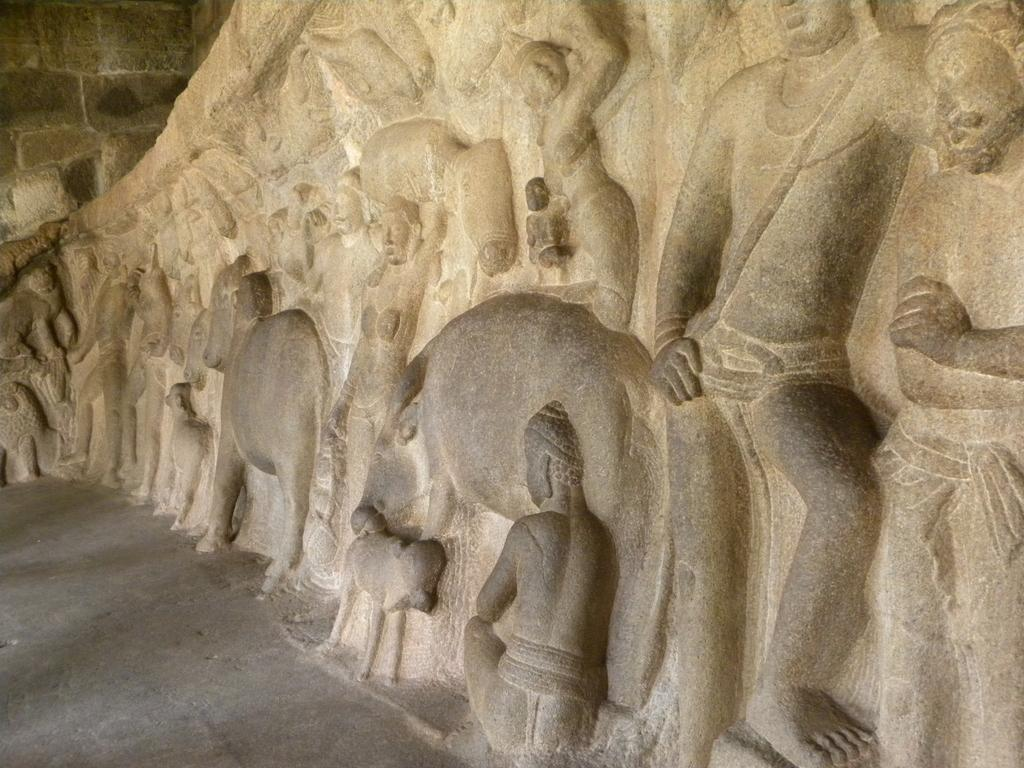What is present on the wall in the image? The wall has sculptures of persons and animals. Can you describe the subjects of the sculptures on the wall? The sculptures on the wall depict both persons and animals. What type of rose can be seen growing on the wall in the image? There is no rose present on the wall in the image; the wall has sculptures of persons and animals. 